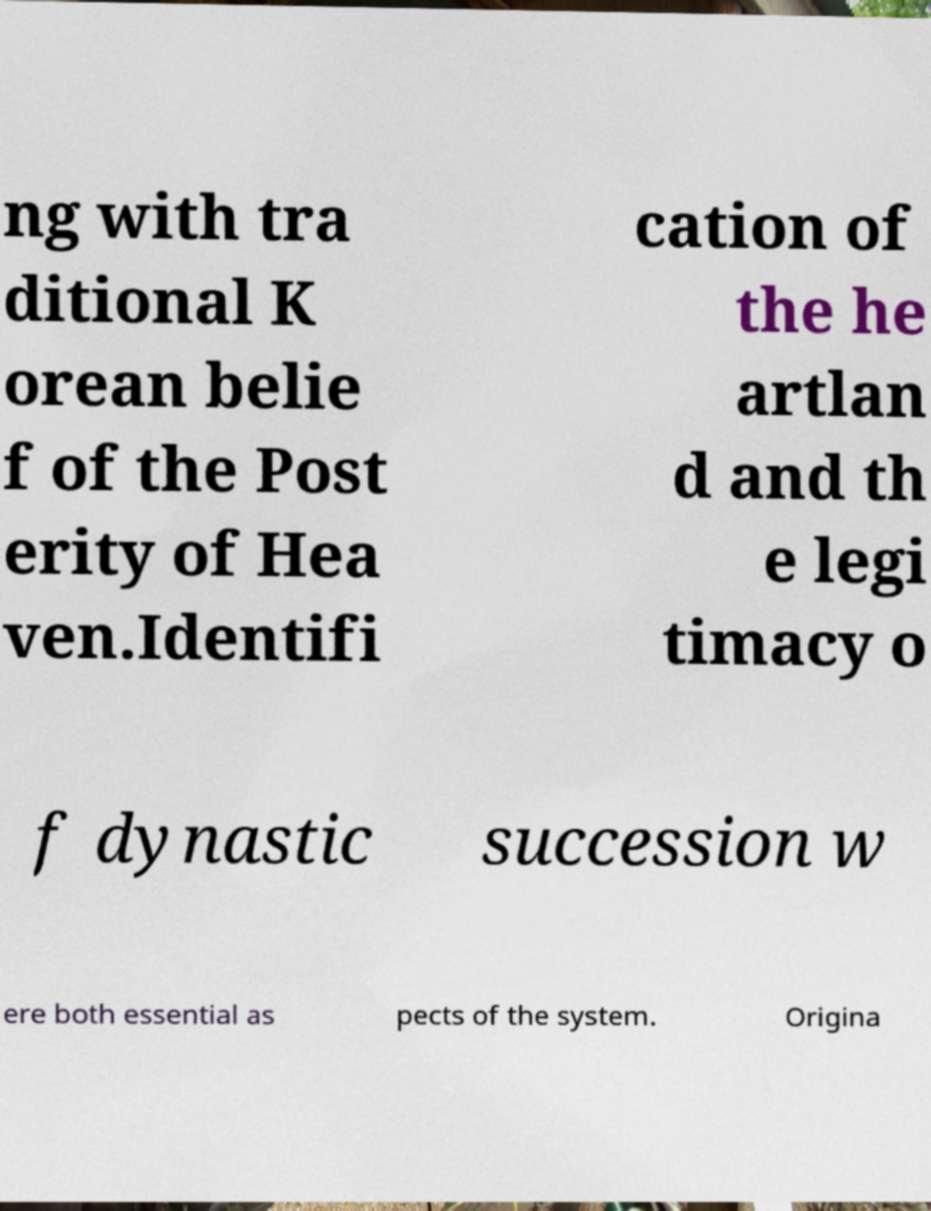What messages or text are displayed in this image? I need them in a readable, typed format. ng with tra ditional K orean belie f of the Post erity of Hea ven.Identifi cation of the he artlan d and th e legi timacy o f dynastic succession w ere both essential as pects of the system. Origina 